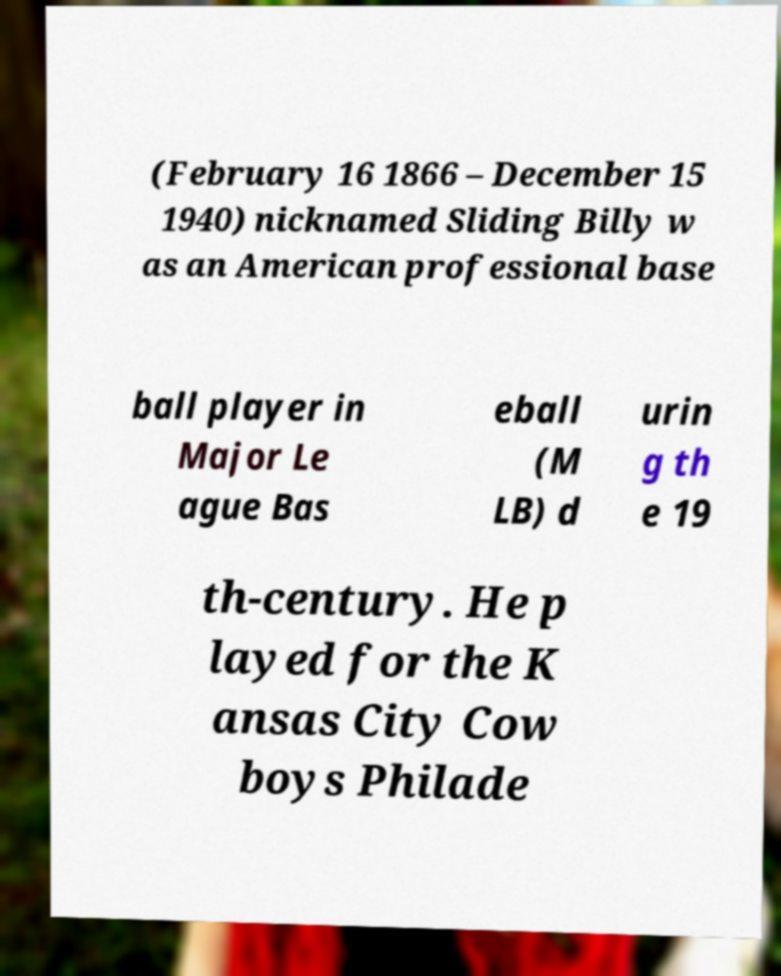Please read and relay the text visible in this image. What does it say? (February 16 1866 – December 15 1940) nicknamed Sliding Billy w as an American professional base ball player in Major Le ague Bas eball (M LB) d urin g th e 19 th-century. He p layed for the K ansas City Cow boys Philade 